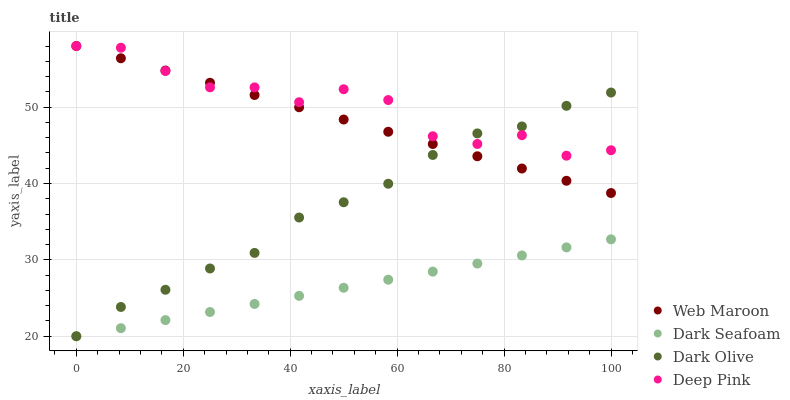Does Dark Seafoam have the minimum area under the curve?
Answer yes or no. Yes. Does Deep Pink have the maximum area under the curve?
Answer yes or no. Yes. Does Dark Olive have the minimum area under the curve?
Answer yes or no. No. Does Dark Olive have the maximum area under the curve?
Answer yes or no. No. Is Dark Seafoam the smoothest?
Answer yes or no. Yes. Is Deep Pink the roughest?
Answer yes or no. Yes. Is Dark Olive the smoothest?
Answer yes or no. No. Is Dark Olive the roughest?
Answer yes or no. No. Does Dark Seafoam have the lowest value?
Answer yes or no. Yes. Does Web Maroon have the lowest value?
Answer yes or no. No. Does Deep Pink have the highest value?
Answer yes or no. Yes. Does Dark Olive have the highest value?
Answer yes or no. No. Is Dark Seafoam less than Deep Pink?
Answer yes or no. Yes. Is Web Maroon greater than Dark Seafoam?
Answer yes or no. Yes. Does Dark Seafoam intersect Dark Olive?
Answer yes or no. Yes. Is Dark Seafoam less than Dark Olive?
Answer yes or no. No. Is Dark Seafoam greater than Dark Olive?
Answer yes or no. No. Does Dark Seafoam intersect Deep Pink?
Answer yes or no. No. 